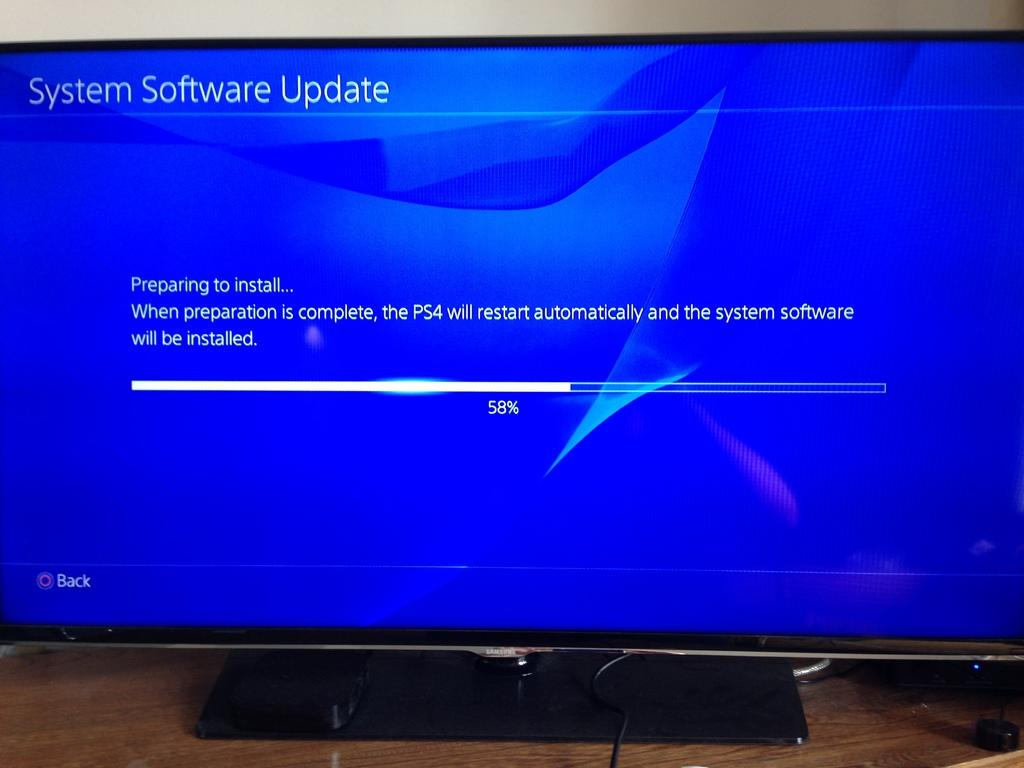<image>
Summarize the visual content of the image. The tv is displaying the progress of the PS4 system software update at 58% complete. 